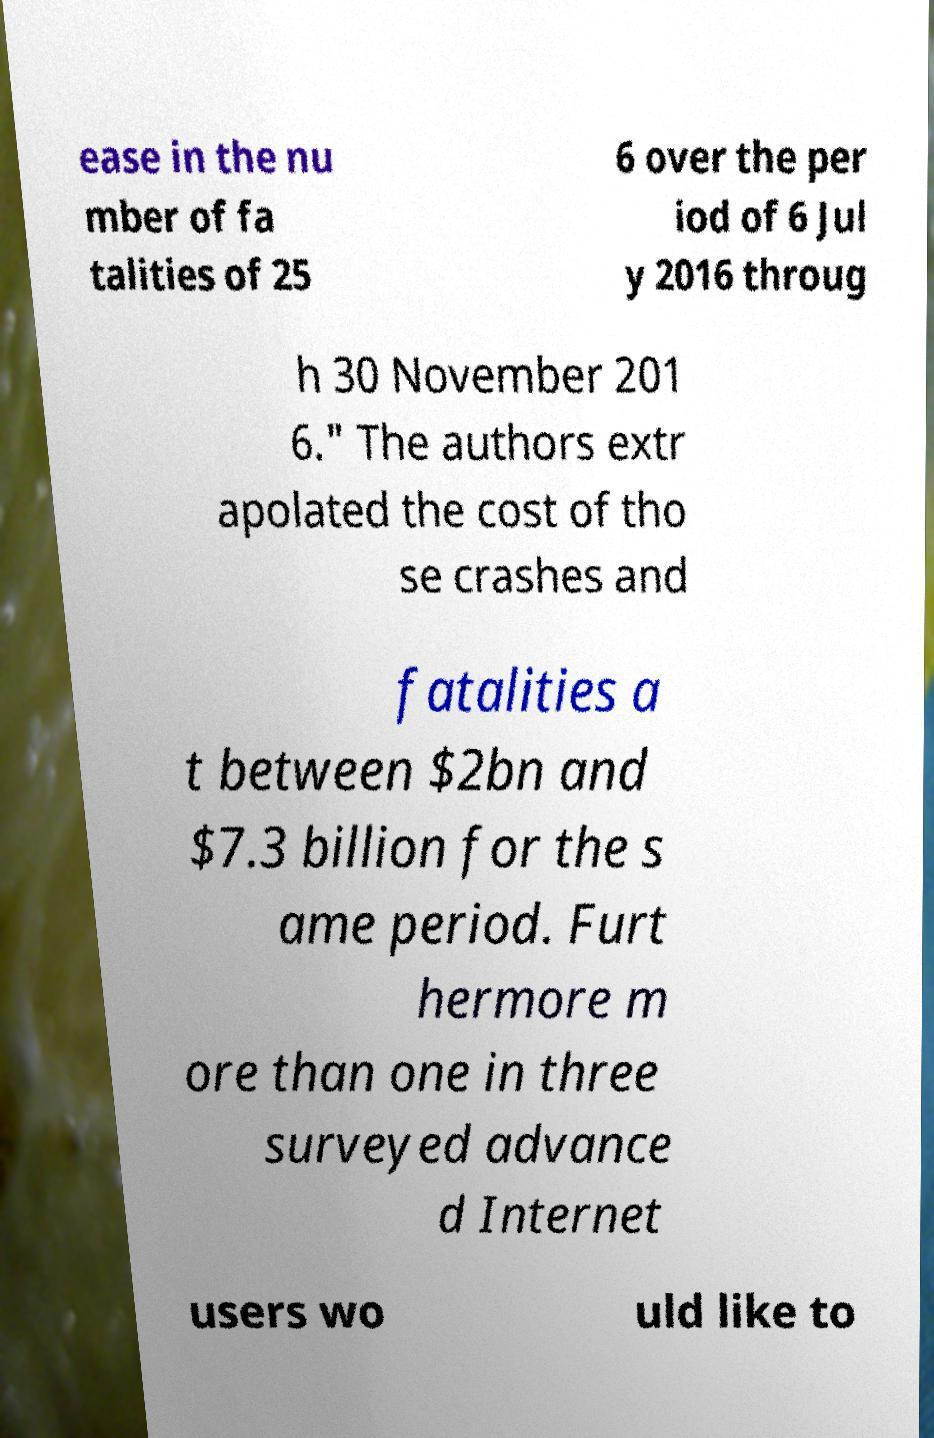What messages or text are displayed in this image? I need them in a readable, typed format. ease in the nu mber of fa talities of 25 6 over the per iod of 6 Jul y 2016 throug h 30 November 201 6." The authors extr apolated the cost of tho se crashes and fatalities a t between $2bn and $7.3 billion for the s ame period. Furt hermore m ore than one in three surveyed advance d Internet users wo uld like to 